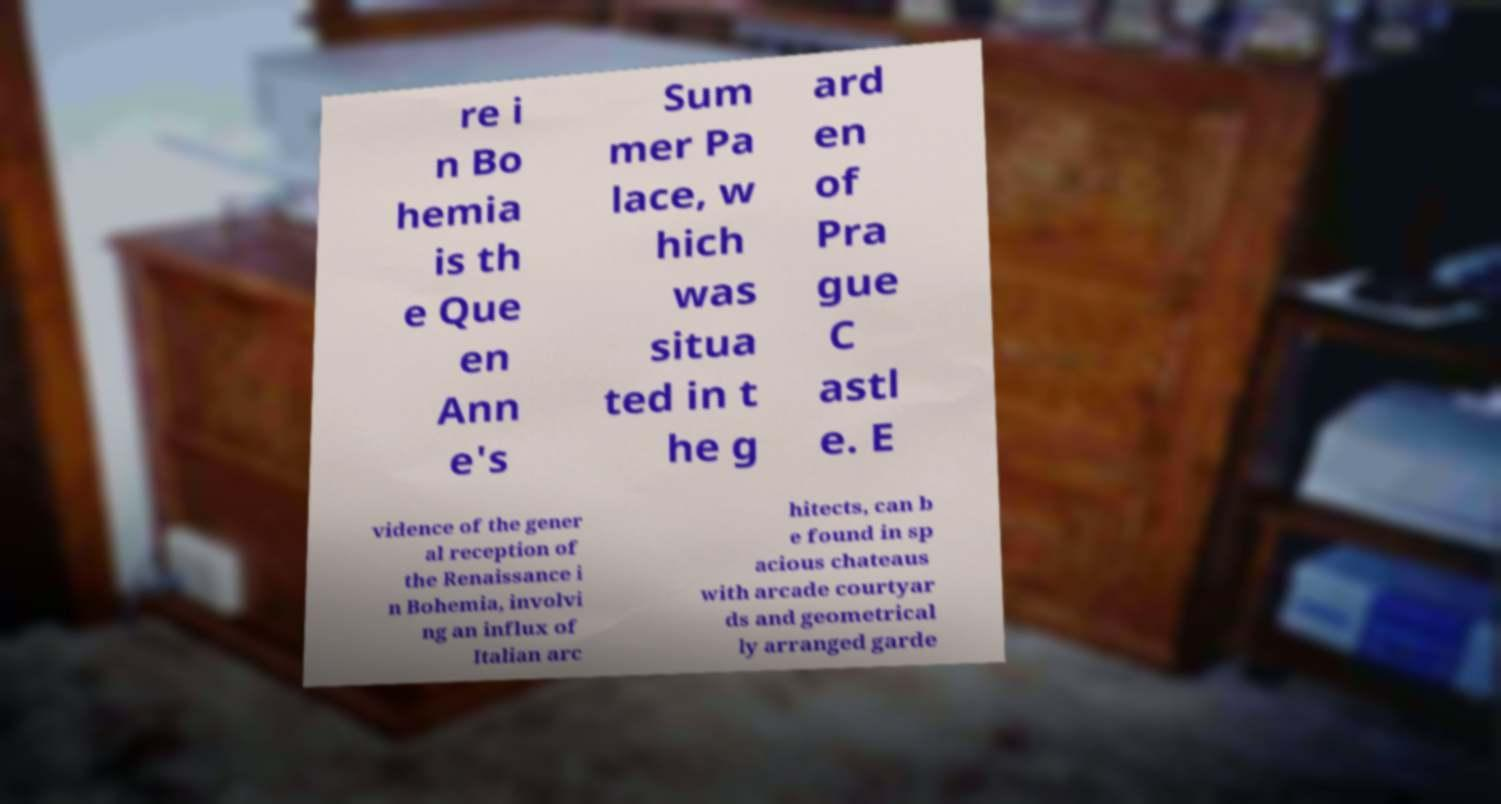For documentation purposes, I need the text within this image transcribed. Could you provide that? re i n Bo hemia is th e Que en Ann e's Sum mer Pa lace, w hich was situa ted in t he g ard en of Pra gue C astl e. E vidence of the gener al reception of the Renaissance i n Bohemia, involvi ng an influx of Italian arc hitects, can b e found in sp acious chateaus with arcade courtyar ds and geometrical ly arranged garde 